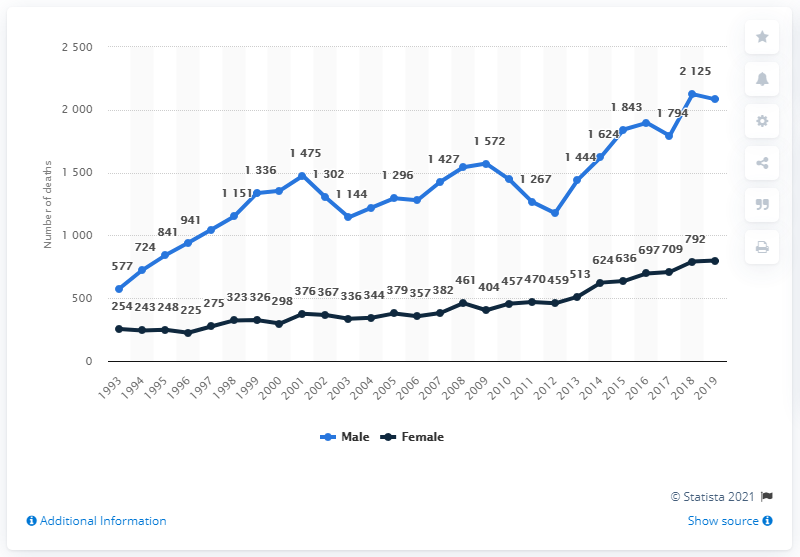Mention a couple of crucial points in this snapshot. The peak value of the blue data line is 2125. Between 1993 and 2019, there were approximately 800 deaths among females as a result of drug misuse. In 1993, the difference between the number of death cases among males and females was smallest. Since 1993, the number of deaths related to drug misuse has increased for both men and women. 